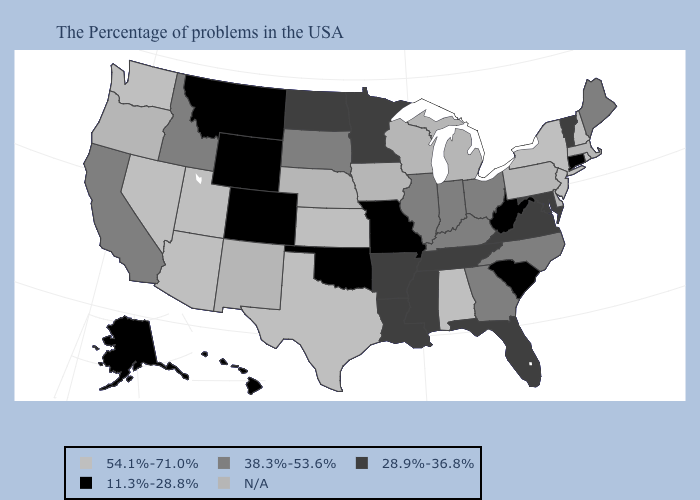Is the legend a continuous bar?
Answer briefly. No. What is the lowest value in the USA?
Keep it brief. 11.3%-28.8%. Does the map have missing data?
Concise answer only. Yes. Name the states that have a value in the range N/A?
Write a very short answer. Massachusetts, Delaware, Pennsylvania, Michigan, Wisconsin, Iowa, Nebraska, New Mexico, Oregon. Among the states that border South Dakota , does Montana have the lowest value?
Be succinct. Yes. Among the states that border Wyoming , which have the lowest value?
Keep it brief. Colorado, Montana. Name the states that have a value in the range 38.3%-53.6%?
Write a very short answer. Maine, North Carolina, Ohio, Georgia, Kentucky, Indiana, Illinois, South Dakota, Idaho, California. What is the lowest value in the Northeast?
Keep it brief. 11.3%-28.8%. Does the first symbol in the legend represent the smallest category?
Be succinct. No. Does the first symbol in the legend represent the smallest category?
Quick response, please. No. Is the legend a continuous bar?
Keep it brief. No. What is the value of Washington?
Answer briefly. 54.1%-71.0%. What is the value of West Virginia?
Write a very short answer. 11.3%-28.8%. 